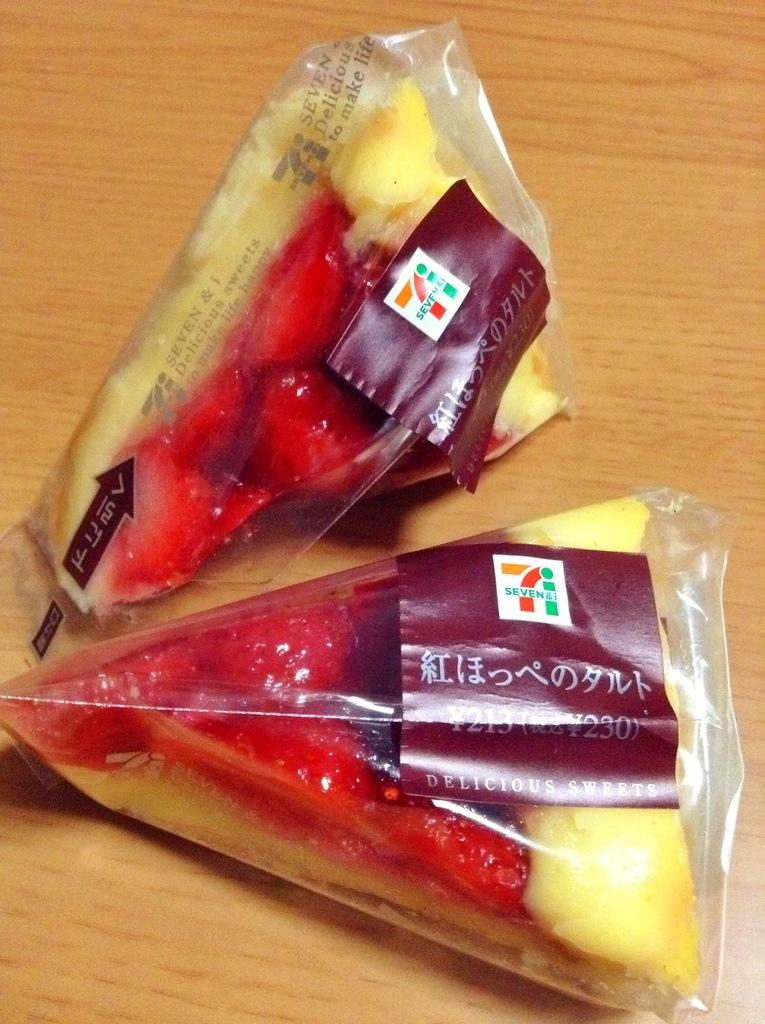What type of furniture is present in the image? There is a table in the image. What can be found on the table in the image? There are food items on the table. What type of disease is depicted in the image? There is no disease depicted in the image; it features a table with food items on it. What type of picture is shown hanging on the wall in the image? There is no picture shown hanging on the wall in the image. 